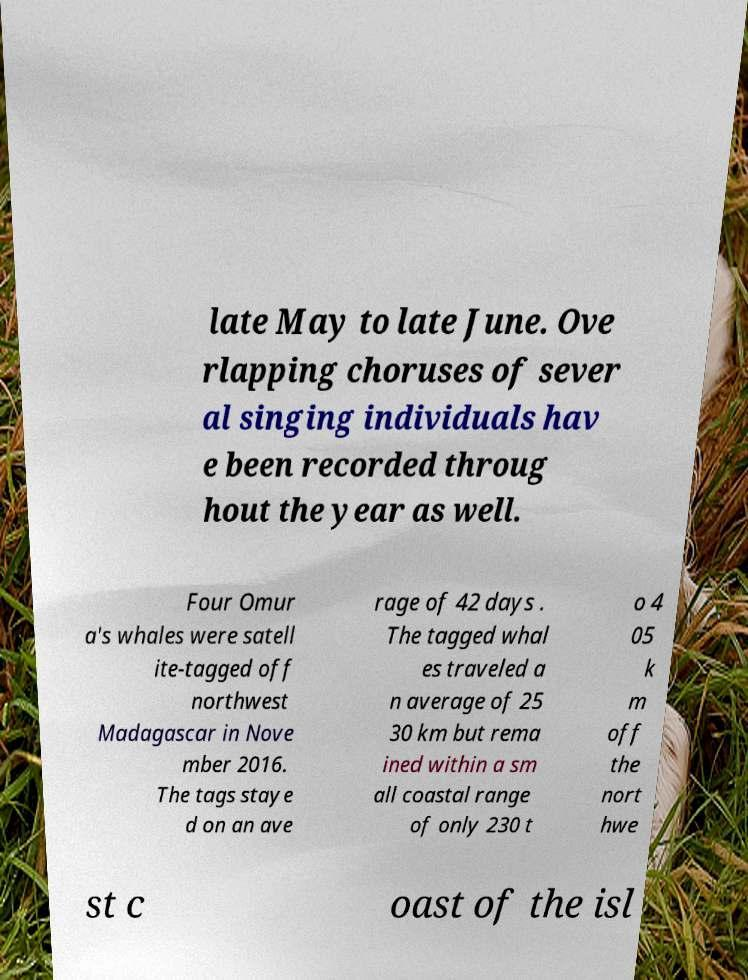Please identify and transcribe the text found in this image. late May to late June. Ove rlapping choruses of sever al singing individuals hav e been recorded throug hout the year as well. Four Omur a's whales were satell ite-tagged off northwest Madagascar in Nove mber 2016. The tags staye d on an ave rage of 42 days . The tagged whal es traveled a n average of 25 30 km but rema ined within a sm all coastal range of only 230 t o 4 05 k m off the nort hwe st c oast of the isl 